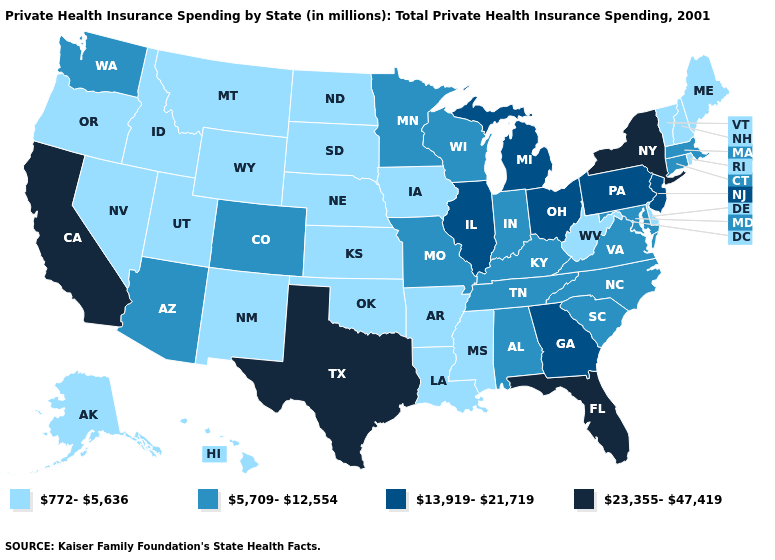What is the value of Colorado?
Quick response, please. 5,709-12,554. What is the value of Wyoming?
Be succinct. 772-5,636. What is the value of Massachusetts?
Answer briefly. 5,709-12,554. What is the value of North Dakota?
Write a very short answer. 772-5,636. Name the states that have a value in the range 23,355-47,419?
Be succinct. California, Florida, New York, Texas. Name the states that have a value in the range 13,919-21,719?
Short answer required. Georgia, Illinois, Michigan, New Jersey, Ohio, Pennsylvania. Does Iowa have a lower value than New Hampshire?
Keep it brief. No. What is the lowest value in the USA?
Be succinct. 772-5,636. What is the value of Oklahoma?
Write a very short answer. 772-5,636. Name the states that have a value in the range 23,355-47,419?
Short answer required. California, Florida, New York, Texas. What is the value of New Mexico?
Give a very brief answer. 772-5,636. Which states hav the highest value in the Northeast?
Be succinct. New York. Does Missouri have the lowest value in the USA?
Quick response, please. No. What is the value of Iowa?
Answer briefly. 772-5,636. Among the states that border Virginia , does West Virginia have the lowest value?
Write a very short answer. Yes. 